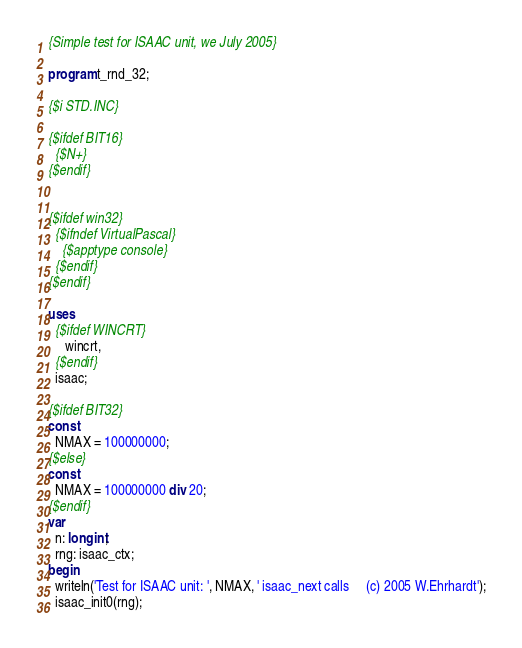<code> <loc_0><loc_0><loc_500><loc_500><_Pascal_>{Simple test for ISAAC unit, we July 2005}

program t_rnd_32;

{$i STD.INC}

{$ifdef BIT16}
  {$N+}
{$endif}


{$ifdef win32}
  {$ifndef VirtualPascal}
    {$apptype console}
  {$endif}
{$endif}

uses
  {$ifdef WINCRT}
     wincrt,
  {$endif}
  isaac;

{$ifdef BIT32}
const
  NMAX = 100000000;
{$else}
const
  NMAX = 100000000 div 20;
{$endif}
var
  n: longint;
  rng: isaac_ctx;
begin
  writeln('Test for ISAAC unit: ', NMAX, ' isaac_next calls     (c) 2005 W.Ehrhardt');
  isaac_init0(rng);</code> 